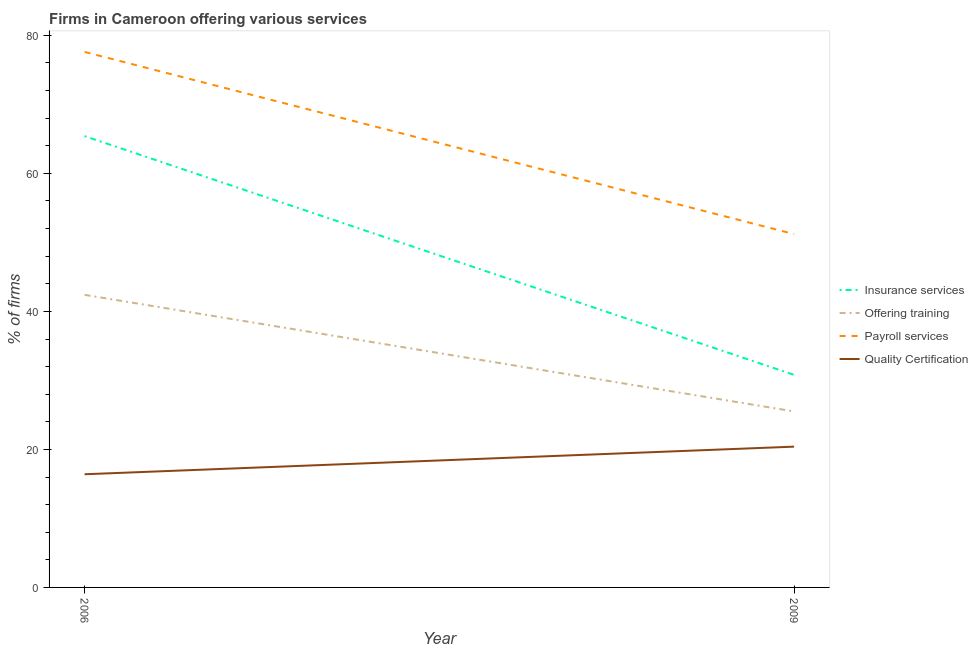How many different coloured lines are there?
Your answer should be very brief. 4. Is the number of lines equal to the number of legend labels?
Keep it short and to the point. Yes. What is the percentage of firms offering training in 2006?
Give a very brief answer. 42.4. Across all years, what is the maximum percentage of firms offering training?
Ensure brevity in your answer.  42.4. In which year was the percentage of firms offering payroll services minimum?
Your response must be concise. 2009. What is the total percentage of firms offering quality certification in the graph?
Offer a terse response. 36.8. What is the difference between the percentage of firms offering training in 2006 and that in 2009?
Make the answer very short. 16.9. What is the difference between the percentage of firms offering training in 2009 and the percentage of firms offering insurance services in 2006?
Make the answer very short. -39.9. What is the average percentage of firms offering insurance services per year?
Provide a short and direct response. 48.1. In the year 2009, what is the difference between the percentage of firms offering quality certification and percentage of firms offering payroll services?
Offer a terse response. -30.8. What is the ratio of the percentage of firms offering insurance services in 2006 to that in 2009?
Your answer should be very brief. 2.12. Is the percentage of firms offering quality certification in 2006 less than that in 2009?
Provide a short and direct response. Yes. In how many years, is the percentage of firms offering training greater than the average percentage of firms offering training taken over all years?
Offer a terse response. 1. Is it the case that in every year, the sum of the percentage of firms offering insurance services and percentage of firms offering training is greater than the percentage of firms offering payroll services?
Your answer should be compact. Yes. Does the percentage of firms offering quality certification monotonically increase over the years?
Provide a short and direct response. Yes. How many years are there in the graph?
Provide a succinct answer. 2. Does the graph contain any zero values?
Ensure brevity in your answer.  No. Does the graph contain grids?
Offer a terse response. No. Where does the legend appear in the graph?
Give a very brief answer. Center right. What is the title of the graph?
Offer a very short reply. Firms in Cameroon offering various services . Does "Australia" appear as one of the legend labels in the graph?
Offer a terse response. No. What is the label or title of the X-axis?
Offer a terse response. Year. What is the label or title of the Y-axis?
Offer a very short reply. % of firms. What is the % of firms of Insurance services in 2006?
Keep it short and to the point. 65.4. What is the % of firms in Offering training in 2006?
Keep it short and to the point. 42.4. What is the % of firms in Payroll services in 2006?
Your response must be concise. 77.6. What is the % of firms of Insurance services in 2009?
Provide a short and direct response. 30.8. What is the % of firms in Offering training in 2009?
Offer a very short reply. 25.5. What is the % of firms in Payroll services in 2009?
Your answer should be compact. 51.2. What is the % of firms of Quality Certification in 2009?
Provide a short and direct response. 20.4. Across all years, what is the maximum % of firms of Insurance services?
Make the answer very short. 65.4. Across all years, what is the maximum % of firms of Offering training?
Make the answer very short. 42.4. Across all years, what is the maximum % of firms in Payroll services?
Give a very brief answer. 77.6. Across all years, what is the maximum % of firms of Quality Certification?
Offer a very short reply. 20.4. Across all years, what is the minimum % of firms of Insurance services?
Provide a succinct answer. 30.8. Across all years, what is the minimum % of firms of Payroll services?
Your answer should be very brief. 51.2. Across all years, what is the minimum % of firms in Quality Certification?
Give a very brief answer. 16.4. What is the total % of firms of Insurance services in the graph?
Your answer should be compact. 96.2. What is the total % of firms of Offering training in the graph?
Offer a very short reply. 67.9. What is the total % of firms of Payroll services in the graph?
Your answer should be very brief. 128.8. What is the total % of firms of Quality Certification in the graph?
Keep it short and to the point. 36.8. What is the difference between the % of firms in Insurance services in 2006 and that in 2009?
Your response must be concise. 34.6. What is the difference between the % of firms of Offering training in 2006 and that in 2009?
Offer a terse response. 16.9. What is the difference between the % of firms in Payroll services in 2006 and that in 2009?
Provide a succinct answer. 26.4. What is the difference between the % of firms in Insurance services in 2006 and the % of firms in Offering training in 2009?
Give a very brief answer. 39.9. What is the difference between the % of firms in Insurance services in 2006 and the % of firms in Payroll services in 2009?
Your response must be concise. 14.2. What is the difference between the % of firms of Insurance services in 2006 and the % of firms of Quality Certification in 2009?
Your answer should be compact. 45. What is the difference between the % of firms of Offering training in 2006 and the % of firms of Payroll services in 2009?
Give a very brief answer. -8.8. What is the difference between the % of firms in Payroll services in 2006 and the % of firms in Quality Certification in 2009?
Your answer should be very brief. 57.2. What is the average % of firms in Insurance services per year?
Provide a succinct answer. 48.1. What is the average % of firms of Offering training per year?
Provide a succinct answer. 33.95. What is the average % of firms in Payroll services per year?
Ensure brevity in your answer.  64.4. In the year 2006, what is the difference between the % of firms of Insurance services and % of firms of Offering training?
Offer a very short reply. 23. In the year 2006, what is the difference between the % of firms in Insurance services and % of firms in Quality Certification?
Offer a very short reply. 49. In the year 2006, what is the difference between the % of firms of Offering training and % of firms of Payroll services?
Your answer should be compact. -35.2. In the year 2006, what is the difference between the % of firms of Offering training and % of firms of Quality Certification?
Provide a short and direct response. 26. In the year 2006, what is the difference between the % of firms of Payroll services and % of firms of Quality Certification?
Your response must be concise. 61.2. In the year 2009, what is the difference between the % of firms in Insurance services and % of firms in Payroll services?
Your answer should be compact. -20.4. In the year 2009, what is the difference between the % of firms of Insurance services and % of firms of Quality Certification?
Provide a short and direct response. 10.4. In the year 2009, what is the difference between the % of firms of Offering training and % of firms of Payroll services?
Provide a succinct answer. -25.7. In the year 2009, what is the difference between the % of firms in Payroll services and % of firms in Quality Certification?
Offer a very short reply. 30.8. What is the ratio of the % of firms in Insurance services in 2006 to that in 2009?
Your response must be concise. 2.12. What is the ratio of the % of firms of Offering training in 2006 to that in 2009?
Ensure brevity in your answer.  1.66. What is the ratio of the % of firms of Payroll services in 2006 to that in 2009?
Make the answer very short. 1.52. What is the ratio of the % of firms of Quality Certification in 2006 to that in 2009?
Give a very brief answer. 0.8. What is the difference between the highest and the second highest % of firms of Insurance services?
Your answer should be compact. 34.6. What is the difference between the highest and the second highest % of firms of Offering training?
Provide a succinct answer. 16.9. What is the difference between the highest and the second highest % of firms of Payroll services?
Your answer should be compact. 26.4. What is the difference between the highest and the lowest % of firms of Insurance services?
Ensure brevity in your answer.  34.6. What is the difference between the highest and the lowest % of firms in Offering training?
Your answer should be very brief. 16.9. What is the difference between the highest and the lowest % of firms of Payroll services?
Your response must be concise. 26.4. What is the difference between the highest and the lowest % of firms of Quality Certification?
Give a very brief answer. 4. 